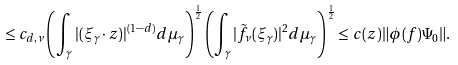Convert formula to latex. <formula><loc_0><loc_0><loc_500><loc_500>\leq c _ { d , \nu } \left ( \int _ { \gamma } | ( \xi _ { \gamma } \cdot z ) | ^ { ( 1 - d ) } d \mu _ { \gamma } \right ) ^ { \frac { 1 } { 2 } } \left ( \int _ { \gamma } | { \tilde { f _ { \nu } } } ( \xi _ { \gamma } ) | ^ { 2 } d \mu _ { \gamma } \right ) ^ { \frac { 1 } { 2 } } \leq c ( z ) \| \phi ( f ) \Psi _ { 0 } \| .</formula> 